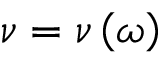<formula> <loc_0><loc_0><loc_500><loc_500>\nu = \nu \left ( \omega \right )</formula> 